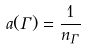Convert formula to latex. <formula><loc_0><loc_0><loc_500><loc_500>a ( \Gamma ) = \frac { 1 } { n _ { \Gamma } }</formula> 